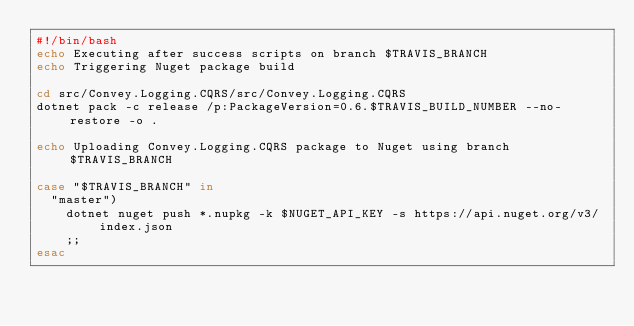Convert code to text. <code><loc_0><loc_0><loc_500><loc_500><_Bash_>#!/bin/bash
echo Executing after success scripts on branch $TRAVIS_BRANCH
echo Triggering Nuget package build

cd src/Convey.Logging.CQRS/src/Convey.Logging.CQRS
dotnet pack -c release /p:PackageVersion=0.6.$TRAVIS_BUILD_NUMBER --no-restore -o .

echo Uploading Convey.Logging.CQRS package to Nuget using branch $TRAVIS_BRANCH

case "$TRAVIS_BRANCH" in
  "master")
    dotnet nuget push *.nupkg -k $NUGET_API_KEY -s https://api.nuget.org/v3/index.json
    ;;
esac</code> 